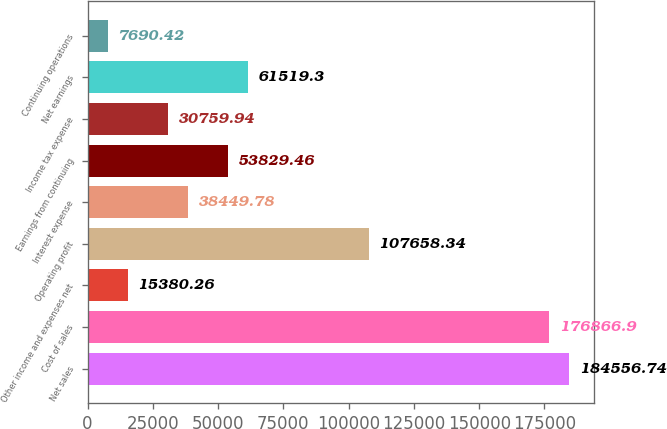Convert chart to OTSL. <chart><loc_0><loc_0><loc_500><loc_500><bar_chart><fcel>Net sales<fcel>Cost of sales<fcel>Other income and expenses net<fcel>Operating profit<fcel>Interest expense<fcel>Earnings from continuing<fcel>Income tax expense<fcel>Net earnings<fcel>Continuing operations<nl><fcel>184557<fcel>176867<fcel>15380.3<fcel>107658<fcel>38449.8<fcel>53829.5<fcel>30759.9<fcel>61519.3<fcel>7690.42<nl></chart> 